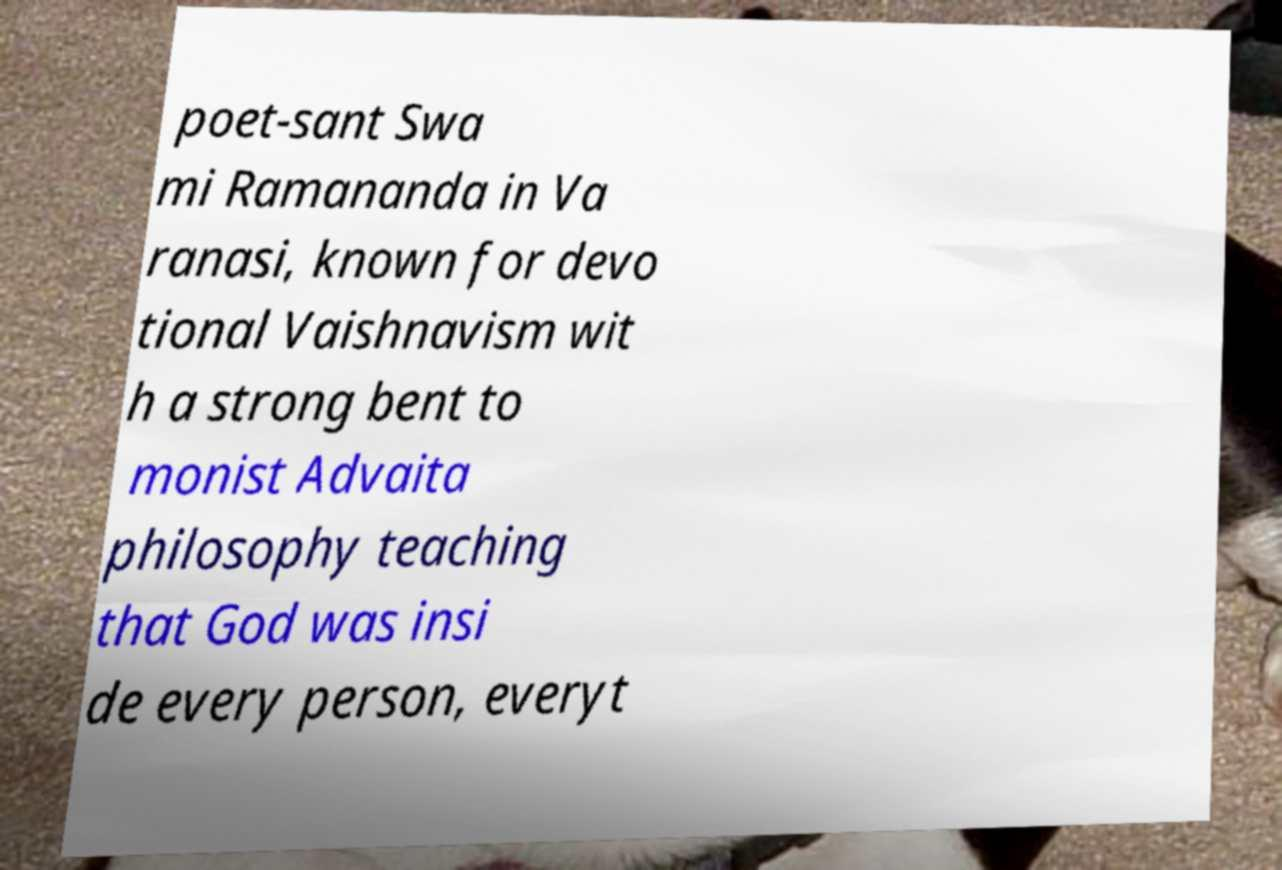There's text embedded in this image that I need extracted. Can you transcribe it verbatim? poet-sant Swa mi Ramananda in Va ranasi, known for devo tional Vaishnavism wit h a strong bent to monist Advaita philosophy teaching that God was insi de every person, everyt 